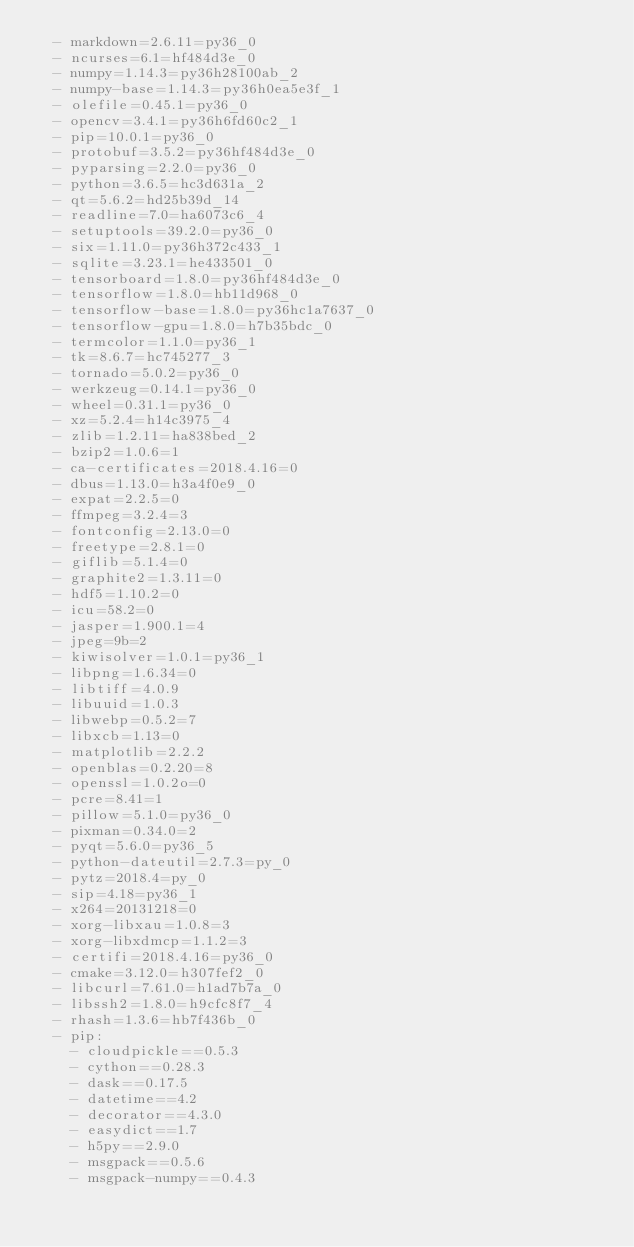<code> <loc_0><loc_0><loc_500><loc_500><_YAML_>  - markdown=2.6.11=py36_0
  - ncurses=6.1=hf484d3e_0
  - numpy=1.14.3=py36h28100ab_2
  - numpy-base=1.14.3=py36h0ea5e3f_1
  - olefile=0.45.1=py36_0
  - opencv=3.4.1=py36h6fd60c2_1
  - pip=10.0.1=py36_0
  - protobuf=3.5.2=py36hf484d3e_0
  - pyparsing=2.2.0=py36_0
  - python=3.6.5=hc3d631a_2
  - qt=5.6.2=hd25b39d_14
  - readline=7.0=ha6073c6_4
  - setuptools=39.2.0=py36_0
  - six=1.11.0=py36h372c433_1
  - sqlite=3.23.1=he433501_0
  - tensorboard=1.8.0=py36hf484d3e_0
  - tensorflow=1.8.0=hb11d968_0
  - tensorflow-base=1.8.0=py36hc1a7637_0
  - tensorflow-gpu=1.8.0=h7b35bdc_0
  - termcolor=1.1.0=py36_1
  - tk=8.6.7=hc745277_3
  - tornado=5.0.2=py36_0
  - werkzeug=0.14.1=py36_0
  - wheel=0.31.1=py36_0
  - xz=5.2.4=h14c3975_4
  - zlib=1.2.11=ha838bed_2
  - bzip2=1.0.6=1
  - ca-certificates=2018.4.16=0
  - dbus=1.13.0=h3a4f0e9_0
  - expat=2.2.5=0
  - ffmpeg=3.2.4=3
  - fontconfig=2.13.0=0
  - freetype=2.8.1=0
  - giflib=5.1.4=0
  - graphite2=1.3.11=0
  - hdf5=1.10.2=0
  - icu=58.2=0
  - jasper=1.900.1=4
  - jpeg=9b=2
  - kiwisolver=1.0.1=py36_1
  - libpng=1.6.34=0
  - libtiff=4.0.9
  - libuuid=1.0.3
  - libwebp=0.5.2=7
  - libxcb=1.13=0
  - matplotlib=2.2.2
  - openblas=0.2.20=8
  - openssl=1.0.2o=0
  - pcre=8.41=1
  - pillow=5.1.0=py36_0
  - pixman=0.34.0=2
  - pyqt=5.6.0=py36_5
  - python-dateutil=2.7.3=py_0
  - pytz=2018.4=py_0
  - sip=4.18=py36_1
  - x264=20131218=0
  - xorg-libxau=1.0.8=3
  - xorg-libxdmcp=1.1.2=3
  - certifi=2018.4.16=py36_0
  - cmake=3.12.0=h307fef2_0
  - libcurl=7.61.0=h1ad7b7a_0
  - libssh2=1.8.0=h9cfc8f7_4
  - rhash=1.3.6=hb7f436b_0
  - pip:
    - cloudpickle==0.5.3
    - cython==0.28.3
    - dask==0.17.5
    - datetime==4.2
    - decorator==4.3.0
    - easydict==1.7
    - h5py==2.9.0
    - msgpack==0.5.6
    - msgpack-numpy==0.4.3</code> 